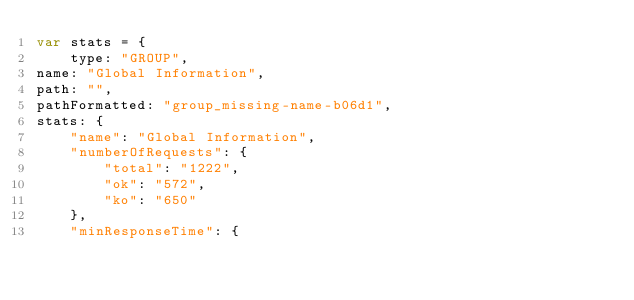Convert code to text. <code><loc_0><loc_0><loc_500><loc_500><_JavaScript_>var stats = {
    type: "GROUP",
name: "Global Information",
path: "",
pathFormatted: "group_missing-name-b06d1",
stats: {
    "name": "Global Information",
    "numberOfRequests": {
        "total": "1222",
        "ok": "572",
        "ko": "650"
    },
    "minResponseTime": {</code> 